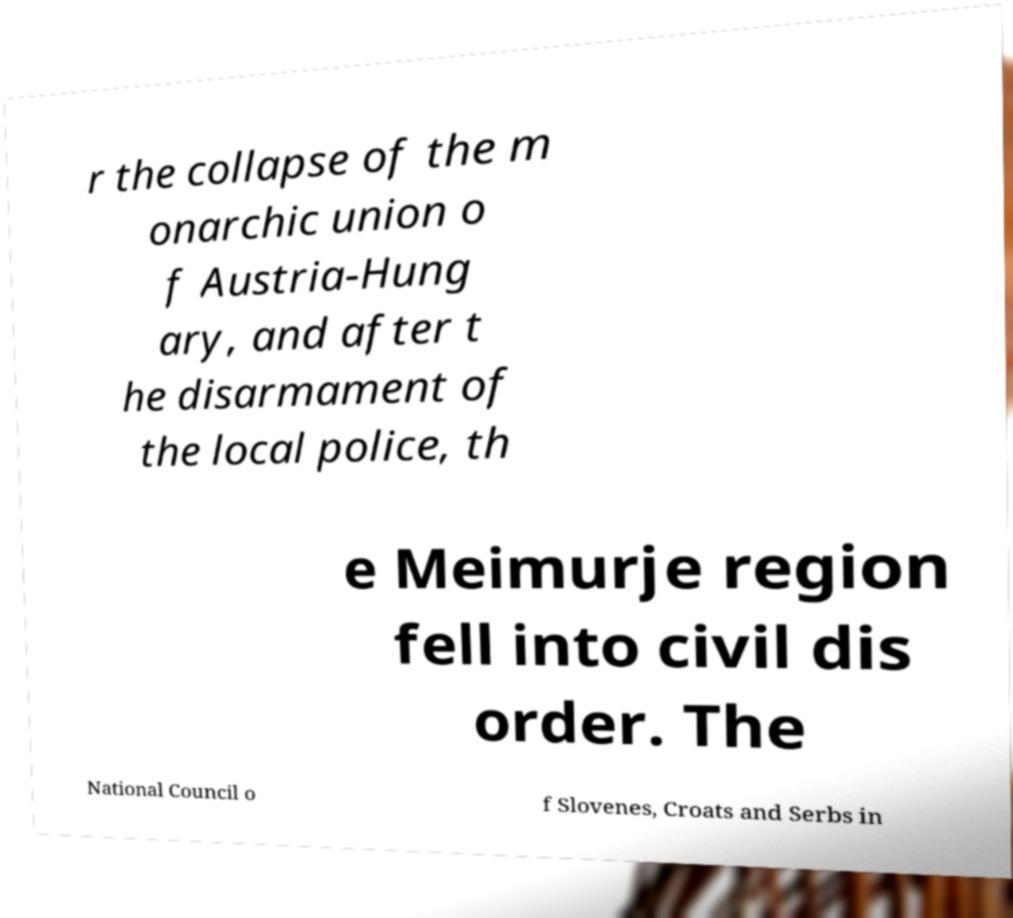Can you accurately transcribe the text from the provided image for me? r the collapse of the m onarchic union o f Austria-Hung ary, and after t he disarmament of the local police, th e Meimurje region fell into civil dis order. The National Council o f Slovenes, Croats and Serbs in 